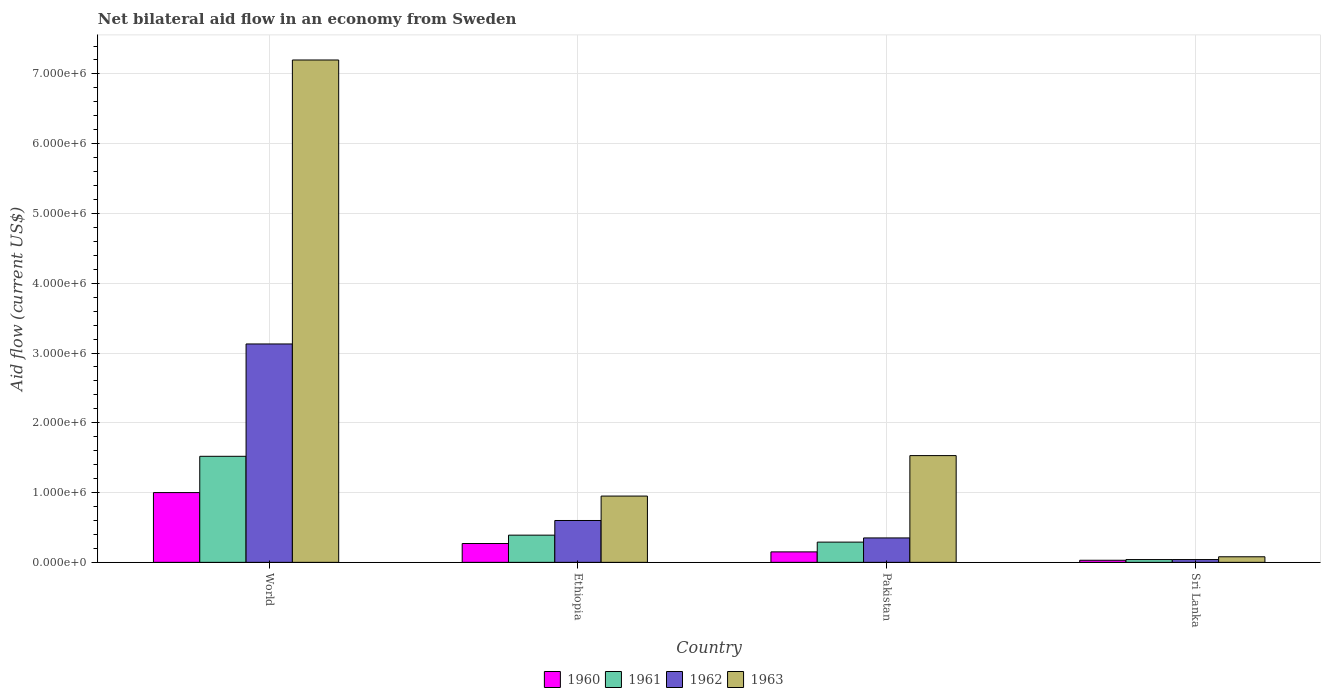How many different coloured bars are there?
Your response must be concise. 4. How many groups of bars are there?
Ensure brevity in your answer.  4. Are the number of bars per tick equal to the number of legend labels?
Offer a terse response. Yes. Are the number of bars on each tick of the X-axis equal?
Your answer should be very brief. Yes. How many bars are there on the 4th tick from the right?
Offer a very short reply. 4. Across all countries, what is the maximum net bilateral aid flow in 1960?
Offer a very short reply. 1.00e+06. In which country was the net bilateral aid flow in 1963 maximum?
Your response must be concise. World. In which country was the net bilateral aid flow in 1961 minimum?
Give a very brief answer. Sri Lanka. What is the total net bilateral aid flow in 1961 in the graph?
Make the answer very short. 2.24e+06. What is the difference between the net bilateral aid flow in 1963 in Ethiopia and that in Sri Lanka?
Offer a terse response. 8.70e+05. What is the difference between the net bilateral aid flow in 1963 in World and the net bilateral aid flow in 1960 in Sri Lanka?
Your response must be concise. 7.17e+06. What is the average net bilateral aid flow in 1961 per country?
Ensure brevity in your answer.  5.60e+05. What is the ratio of the net bilateral aid flow in 1962 in Pakistan to that in Sri Lanka?
Ensure brevity in your answer.  8.75. Is the net bilateral aid flow in 1960 in Sri Lanka less than that in World?
Give a very brief answer. Yes. What is the difference between the highest and the second highest net bilateral aid flow in 1961?
Make the answer very short. 1.13e+06. What is the difference between the highest and the lowest net bilateral aid flow in 1960?
Your answer should be very brief. 9.70e+05. Is it the case that in every country, the sum of the net bilateral aid flow in 1962 and net bilateral aid flow in 1960 is greater than the sum of net bilateral aid flow in 1961 and net bilateral aid flow in 1963?
Provide a succinct answer. No. What does the 2nd bar from the right in World represents?
Provide a short and direct response. 1962. Is it the case that in every country, the sum of the net bilateral aid flow in 1963 and net bilateral aid flow in 1961 is greater than the net bilateral aid flow in 1962?
Offer a very short reply. Yes. Are all the bars in the graph horizontal?
Offer a terse response. No. How many countries are there in the graph?
Your answer should be compact. 4. What is the difference between two consecutive major ticks on the Y-axis?
Offer a very short reply. 1.00e+06. Are the values on the major ticks of Y-axis written in scientific E-notation?
Your response must be concise. Yes. Does the graph contain any zero values?
Your answer should be compact. No. How are the legend labels stacked?
Your response must be concise. Horizontal. What is the title of the graph?
Provide a succinct answer. Net bilateral aid flow in an economy from Sweden. What is the label or title of the X-axis?
Keep it short and to the point. Country. What is the label or title of the Y-axis?
Your response must be concise. Aid flow (current US$). What is the Aid flow (current US$) of 1961 in World?
Offer a terse response. 1.52e+06. What is the Aid flow (current US$) in 1962 in World?
Your answer should be compact. 3.13e+06. What is the Aid flow (current US$) in 1963 in World?
Keep it short and to the point. 7.20e+06. What is the Aid flow (current US$) in 1962 in Ethiopia?
Keep it short and to the point. 6.00e+05. What is the Aid flow (current US$) in 1963 in Ethiopia?
Your response must be concise. 9.50e+05. What is the Aid flow (current US$) of 1963 in Pakistan?
Make the answer very short. 1.53e+06. What is the Aid flow (current US$) of 1962 in Sri Lanka?
Your response must be concise. 4.00e+04. Across all countries, what is the maximum Aid flow (current US$) in 1961?
Make the answer very short. 1.52e+06. Across all countries, what is the maximum Aid flow (current US$) of 1962?
Your answer should be very brief. 3.13e+06. Across all countries, what is the maximum Aid flow (current US$) in 1963?
Offer a very short reply. 7.20e+06. Across all countries, what is the minimum Aid flow (current US$) in 1961?
Your answer should be very brief. 4.00e+04. Across all countries, what is the minimum Aid flow (current US$) in 1962?
Keep it short and to the point. 4.00e+04. What is the total Aid flow (current US$) in 1960 in the graph?
Ensure brevity in your answer.  1.45e+06. What is the total Aid flow (current US$) of 1961 in the graph?
Make the answer very short. 2.24e+06. What is the total Aid flow (current US$) in 1962 in the graph?
Make the answer very short. 4.12e+06. What is the total Aid flow (current US$) of 1963 in the graph?
Offer a very short reply. 9.76e+06. What is the difference between the Aid flow (current US$) in 1960 in World and that in Ethiopia?
Offer a terse response. 7.30e+05. What is the difference between the Aid flow (current US$) in 1961 in World and that in Ethiopia?
Provide a short and direct response. 1.13e+06. What is the difference between the Aid flow (current US$) of 1962 in World and that in Ethiopia?
Offer a terse response. 2.53e+06. What is the difference between the Aid flow (current US$) in 1963 in World and that in Ethiopia?
Offer a very short reply. 6.25e+06. What is the difference between the Aid flow (current US$) of 1960 in World and that in Pakistan?
Offer a terse response. 8.50e+05. What is the difference between the Aid flow (current US$) of 1961 in World and that in Pakistan?
Provide a succinct answer. 1.23e+06. What is the difference between the Aid flow (current US$) of 1962 in World and that in Pakistan?
Provide a succinct answer. 2.78e+06. What is the difference between the Aid flow (current US$) of 1963 in World and that in Pakistan?
Ensure brevity in your answer.  5.67e+06. What is the difference between the Aid flow (current US$) of 1960 in World and that in Sri Lanka?
Offer a terse response. 9.70e+05. What is the difference between the Aid flow (current US$) in 1961 in World and that in Sri Lanka?
Your answer should be compact. 1.48e+06. What is the difference between the Aid flow (current US$) in 1962 in World and that in Sri Lanka?
Your response must be concise. 3.09e+06. What is the difference between the Aid flow (current US$) of 1963 in World and that in Sri Lanka?
Offer a terse response. 7.12e+06. What is the difference between the Aid flow (current US$) of 1960 in Ethiopia and that in Pakistan?
Offer a terse response. 1.20e+05. What is the difference between the Aid flow (current US$) of 1961 in Ethiopia and that in Pakistan?
Your answer should be compact. 1.00e+05. What is the difference between the Aid flow (current US$) of 1962 in Ethiopia and that in Pakistan?
Keep it short and to the point. 2.50e+05. What is the difference between the Aid flow (current US$) of 1963 in Ethiopia and that in Pakistan?
Your response must be concise. -5.80e+05. What is the difference between the Aid flow (current US$) of 1961 in Ethiopia and that in Sri Lanka?
Offer a terse response. 3.50e+05. What is the difference between the Aid flow (current US$) of 1962 in Ethiopia and that in Sri Lanka?
Ensure brevity in your answer.  5.60e+05. What is the difference between the Aid flow (current US$) of 1963 in Ethiopia and that in Sri Lanka?
Make the answer very short. 8.70e+05. What is the difference between the Aid flow (current US$) in 1960 in Pakistan and that in Sri Lanka?
Your answer should be very brief. 1.20e+05. What is the difference between the Aid flow (current US$) of 1963 in Pakistan and that in Sri Lanka?
Your response must be concise. 1.45e+06. What is the difference between the Aid flow (current US$) of 1960 in World and the Aid flow (current US$) of 1962 in Ethiopia?
Your response must be concise. 4.00e+05. What is the difference between the Aid flow (current US$) in 1961 in World and the Aid flow (current US$) in 1962 in Ethiopia?
Give a very brief answer. 9.20e+05. What is the difference between the Aid flow (current US$) of 1961 in World and the Aid flow (current US$) of 1963 in Ethiopia?
Make the answer very short. 5.70e+05. What is the difference between the Aid flow (current US$) in 1962 in World and the Aid flow (current US$) in 1963 in Ethiopia?
Give a very brief answer. 2.18e+06. What is the difference between the Aid flow (current US$) in 1960 in World and the Aid flow (current US$) in 1961 in Pakistan?
Provide a short and direct response. 7.10e+05. What is the difference between the Aid flow (current US$) in 1960 in World and the Aid flow (current US$) in 1962 in Pakistan?
Give a very brief answer. 6.50e+05. What is the difference between the Aid flow (current US$) in 1960 in World and the Aid flow (current US$) in 1963 in Pakistan?
Provide a succinct answer. -5.30e+05. What is the difference between the Aid flow (current US$) of 1961 in World and the Aid flow (current US$) of 1962 in Pakistan?
Keep it short and to the point. 1.17e+06. What is the difference between the Aid flow (current US$) of 1961 in World and the Aid flow (current US$) of 1963 in Pakistan?
Make the answer very short. -10000. What is the difference between the Aid flow (current US$) in 1962 in World and the Aid flow (current US$) in 1963 in Pakistan?
Keep it short and to the point. 1.60e+06. What is the difference between the Aid flow (current US$) in 1960 in World and the Aid flow (current US$) in 1961 in Sri Lanka?
Make the answer very short. 9.60e+05. What is the difference between the Aid flow (current US$) in 1960 in World and the Aid flow (current US$) in 1962 in Sri Lanka?
Make the answer very short. 9.60e+05. What is the difference between the Aid flow (current US$) in 1960 in World and the Aid flow (current US$) in 1963 in Sri Lanka?
Your answer should be compact. 9.20e+05. What is the difference between the Aid flow (current US$) of 1961 in World and the Aid flow (current US$) of 1962 in Sri Lanka?
Your answer should be compact. 1.48e+06. What is the difference between the Aid flow (current US$) in 1961 in World and the Aid flow (current US$) in 1963 in Sri Lanka?
Keep it short and to the point. 1.44e+06. What is the difference between the Aid flow (current US$) in 1962 in World and the Aid flow (current US$) in 1963 in Sri Lanka?
Keep it short and to the point. 3.05e+06. What is the difference between the Aid flow (current US$) of 1960 in Ethiopia and the Aid flow (current US$) of 1961 in Pakistan?
Make the answer very short. -2.00e+04. What is the difference between the Aid flow (current US$) of 1960 in Ethiopia and the Aid flow (current US$) of 1963 in Pakistan?
Ensure brevity in your answer.  -1.26e+06. What is the difference between the Aid flow (current US$) in 1961 in Ethiopia and the Aid flow (current US$) in 1963 in Pakistan?
Offer a terse response. -1.14e+06. What is the difference between the Aid flow (current US$) of 1962 in Ethiopia and the Aid flow (current US$) of 1963 in Pakistan?
Your response must be concise. -9.30e+05. What is the difference between the Aid flow (current US$) of 1960 in Ethiopia and the Aid flow (current US$) of 1963 in Sri Lanka?
Keep it short and to the point. 1.90e+05. What is the difference between the Aid flow (current US$) in 1962 in Ethiopia and the Aid flow (current US$) in 1963 in Sri Lanka?
Your answer should be very brief. 5.20e+05. What is the difference between the Aid flow (current US$) in 1960 in Pakistan and the Aid flow (current US$) in 1962 in Sri Lanka?
Your response must be concise. 1.10e+05. What is the difference between the Aid flow (current US$) of 1960 in Pakistan and the Aid flow (current US$) of 1963 in Sri Lanka?
Your answer should be compact. 7.00e+04. What is the difference between the Aid flow (current US$) in 1961 in Pakistan and the Aid flow (current US$) in 1963 in Sri Lanka?
Ensure brevity in your answer.  2.10e+05. What is the average Aid flow (current US$) in 1960 per country?
Provide a short and direct response. 3.62e+05. What is the average Aid flow (current US$) of 1961 per country?
Provide a succinct answer. 5.60e+05. What is the average Aid flow (current US$) of 1962 per country?
Provide a succinct answer. 1.03e+06. What is the average Aid flow (current US$) of 1963 per country?
Your answer should be very brief. 2.44e+06. What is the difference between the Aid flow (current US$) of 1960 and Aid flow (current US$) of 1961 in World?
Your answer should be compact. -5.20e+05. What is the difference between the Aid flow (current US$) of 1960 and Aid flow (current US$) of 1962 in World?
Offer a terse response. -2.13e+06. What is the difference between the Aid flow (current US$) in 1960 and Aid flow (current US$) in 1963 in World?
Keep it short and to the point. -6.20e+06. What is the difference between the Aid flow (current US$) in 1961 and Aid flow (current US$) in 1962 in World?
Offer a terse response. -1.61e+06. What is the difference between the Aid flow (current US$) in 1961 and Aid flow (current US$) in 1963 in World?
Your answer should be very brief. -5.68e+06. What is the difference between the Aid flow (current US$) of 1962 and Aid flow (current US$) of 1963 in World?
Make the answer very short. -4.07e+06. What is the difference between the Aid flow (current US$) of 1960 and Aid flow (current US$) of 1962 in Ethiopia?
Your answer should be very brief. -3.30e+05. What is the difference between the Aid flow (current US$) of 1960 and Aid flow (current US$) of 1963 in Ethiopia?
Offer a very short reply. -6.80e+05. What is the difference between the Aid flow (current US$) in 1961 and Aid flow (current US$) in 1962 in Ethiopia?
Your answer should be compact. -2.10e+05. What is the difference between the Aid flow (current US$) of 1961 and Aid flow (current US$) of 1963 in Ethiopia?
Your response must be concise. -5.60e+05. What is the difference between the Aid flow (current US$) of 1962 and Aid flow (current US$) of 1963 in Ethiopia?
Offer a very short reply. -3.50e+05. What is the difference between the Aid flow (current US$) in 1960 and Aid flow (current US$) in 1962 in Pakistan?
Ensure brevity in your answer.  -2.00e+05. What is the difference between the Aid flow (current US$) of 1960 and Aid flow (current US$) of 1963 in Pakistan?
Offer a terse response. -1.38e+06. What is the difference between the Aid flow (current US$) of 1961 and Aid flow (current US$) of 1963 in Pakistan?
Make the answer very short. -1.24e+06. What is the difference between the Aid flow (current US$) of 1962 and Aid flow (current US$) of 1963 in Pakistan?
Give a very brief answer. -1.18e+06. What is the difference between the Aid flow (current US$) of 1960 and Aid flow (current US$) of 1961 in Sri Lanka?
Your response must be concise. -10000. What is the difference between the Aid flow (current US$) in 1960 and Aid flow (current US$) in 1962 in Sri Lanka?
Your answer should be compact. -10000. What is the difference between the Aid flow (current US$) in 1960 and Aid flow (current US$) in 1963 in Sri Lanka?
Provide a succinct answer. -5.00e+04. What is the difference between the Aid flow (current US$) of 1961 and Aid flow (current US$) of 1963 in Sri Lanka?
Offer a terse response. -4.00e+04. What is the ratio of the Aid flow (current US$) of 1960 in World to that in Ethiopia?
Keep it short and to the point. 3.7. What is the ratio of the Aid flow (current US$) of 1961 in World to that in Ethiopia?
Make the answer very short. 3.9. What is the ratio of the Aid flow (current US$) of 1962 in World to that in Ethiopia?
Make the answer very short. 5.22. What is the ratio of the Aid flow (current US$) in 1963 in World to that in Ethiopia?
Offer a very short reply. 7.58. What is the ratio of the Aid flow (current US$) of 1960 in World to that in Pakistan?
Keep it short and to the point. 6.67. What is the ratio of the Aid flow (current US$) of 1961 in World to that in Pakistan?
Give a very brief answer. 5.24. What is the ratio of the Aid flow (current US$) in 1962 in World to that in Pakistan?
Offer a very short reply. 8.94. What is the ratio of the Aid flow (current US$) in 1963 in World to that in Pakistan?
Your response must be concise. 4.71. What is the ratio of the Aid flow (current US$) of 1960 in World to that in Sri Lanka?
Your answer should be very brief. 33.33. What is the ratio of the Aid flow (current US$) in 1962 in World to that in Sri Lanka?
Offer a terse response. 78.25. What is the ratio of the Aid flow (current US$) of 1963 in World to that in Sri Lanka?
Ensure brevity in your answer.  90. What is the ratio of the Aid flow (current US$) of 1960 in Ethiopia to that in Pakistan?
Provide a succinct answer. 1.8. What is the ratio of the Aid flow (current US$) in 1961 in Ethiopia to that in Pakistan?
Provide a succinct answer. 1.34. What is the ratio of the Aid flow (current US$) in 1962 in Ethiopia to that in Pakistan?
Your answer should be compact. 1.71. What is the ratio of the Aid flow (current US$) in 1963 in Ethiopia to that in Pakistan?
Your response must be concise. 0.62. What is the ratio of the Aid flow (current US$) in 1961 in Ethiopia to that in Sri Lanka?
Ensure brevity in your answer.  9.75. What is the ratio of the Aid flow (current US$) of 1962 in Ethiopia to that in Sri Lanka?
Give a very brief answer. 15. What is the ratio of the Aid flow (current US$) of 1963 in Ethiopia to that in Sri Lanka?
Ensure brevity in your answer.  11.88. What is the ratio of the Aid flow (current US$) in 1960 in Pakistan to that in Sri Lanka?
Your answer should be very brief. 5. What is the ratio of the Aid flow (current US$) in 1961 in Pakistan to that in Sri Lanka?
Give a very brief answer. 7.25. What is the ratio of the Aid flow (current US$) of 1962 in Pakistan to that in Sri Lanka?
Your answer should be compact. 8.75. What is the ratio of the Aid flow (current US$) of 1963 in Pakistan to that in Sri Lanka?
Provide a short and direct response. 19.12. What is the difference between the highest and the second highest Aid flow (current US$) of 1960?
Provide a succinct answer. 7.30e+05. What is the difference between the highest and the second highest Aid flow (current US$) of 1961?
Ensure brevity in your answer.  1.13e+06. What is the difference between the highest and the second highest Aid flow (current US$) of 1962?
Your answer should be compact. 2.53e+06. What is the difference between the highest and the second highest Aid flow (current US$) in 1963?
Your answer should be very brief. 5.67e+06. What is the difference between the highest and the lowest Aid flow (current US$) in 1960?
Offer a very short reply. 9.70e+05. What is the difference between the highest and the lowest Aid flow (current US$) of 1961?
Your answer should be compact. 1.48e+06. What is the difference between the highest and the lowest Aid flow (current US$) in 1962?
Your answer should be very brief. 3.09e+06. What is the difference between the highest and the lowest Aid flow (current US$) of 1963?
Offer a very short reply. 7.12e+06. 